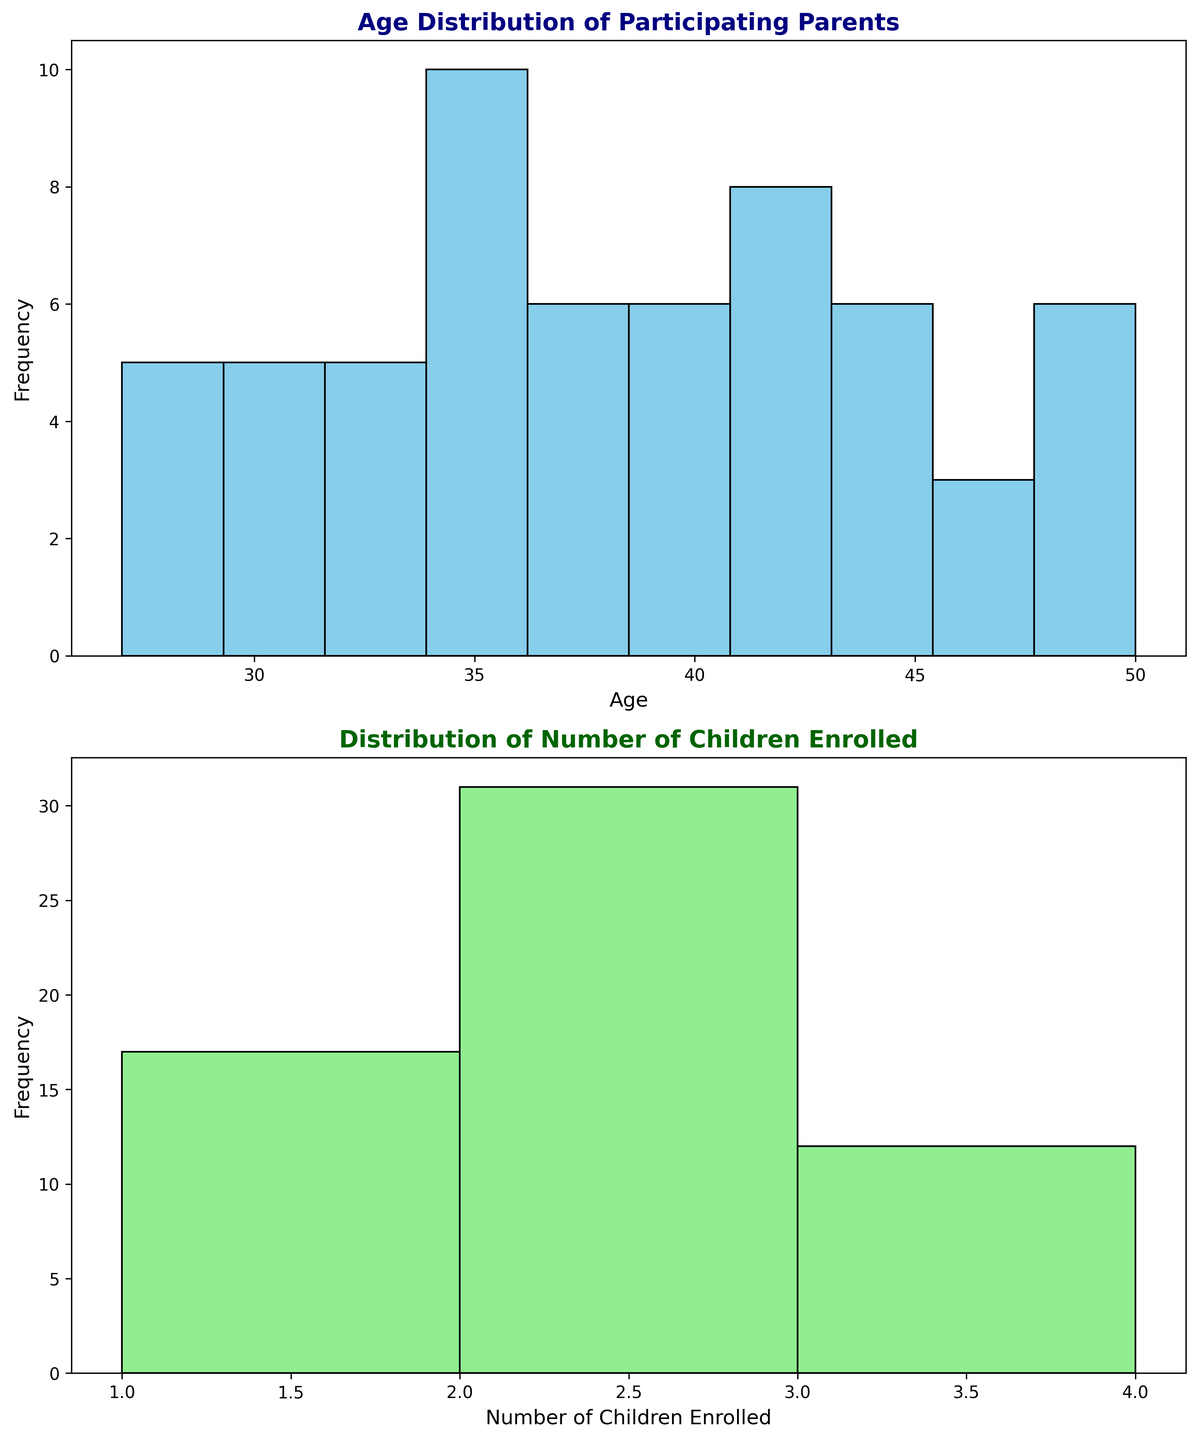What is the range of ages of participating parents? The lowest age is 27, and the highest age is 50. The range is calculated as the difference between the highest and lowest ages, which is 50 - 27.
Answer: 23 How many parents are in the 30-35 age group? By counting the bars corresponding to ages 30, 31, 32, 33, 34, 35 on the histogram, we sum their frequencies.
Answer: 11 Which age group has the highest frequency of participating parents? By visually identifying the tallest bar in the age histogram, we determine that the age group around 31-32 has the highest frequency.
Answer: 31-32 How many parents have three children enrolled? By counting the bars corresponding to '3' in the histogram for Number of Children Enrolled, we sum their frequencies.
Answer: 10 What is the most common number of children enrolled among participating parents? By observing the tallest bar in the histogram for Number of Children Enrolled, we see that "2" is the most common.
Answer: 2 How does the frequency of parents aged 40-45 compare to those aged 35-39? By adding the frequency of bars in the 40-45 age range and comparing it to the 35-39 age range, we notice there are more parents in the 40-45 age group.
Answer: 40-45 has more Is there a noticeable correlation between age and number of children enrolled? By comparing the histograms visually, no strong correlation can be directly observed as the distributions do not exhibit a clear pattern in relation to each other.
Answer: No strong correlation What percentage of participating parents have 1 child enrolled? By dividing the number of parents with 1 child by the total number of participating parents and multiplying by 100, we get the percentage.
Answer: 25% Are parents aged under 30 well-represented among the participating parents? Counting the frequency of parents aged 27-29 and comparing it to other age groups, we see a lower representation.
Answer: No Which age group has the least representation? Counting the frequency of each age group bar in the histogram and identifying the smallest value, parents around age 28-29 have the least representation.
Answer: 28-29 